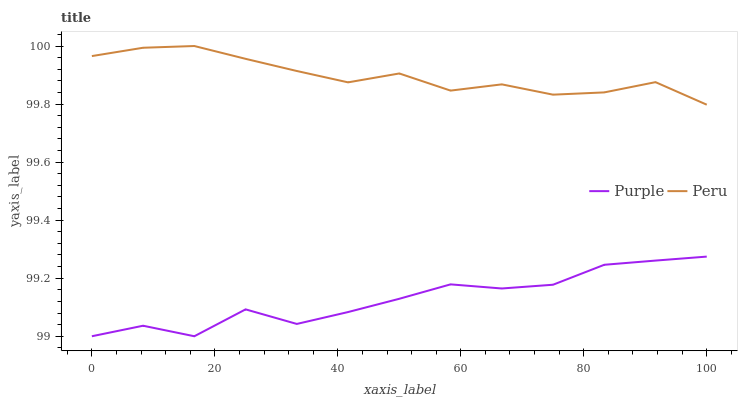Does Purple have the minimum area under the curve?
Answer yes or no. Yes. Does Peru have the maximum area under the curve?
Answer yes or no. Yes. Does Peru have the minimum area under the curve?
Answer yes or no. No. Is Peru the smoothest?
Answer yes or no. Yes. Is Purple the roughest?
Answer yes or no. Yes. Is Peru the roughest?
Answer yes or no. No. Does Peru have the lowest value?
Answer yes or no. No. Does Peru have the highest value?
Answer yes or no. Yes. Is Purple less than Peru?
Answer yes or no. Yes. Is Peru greater than Purple?
Answer yes or no. Yes. Does Purple intersect Peru?
Answer yes or no. No. 